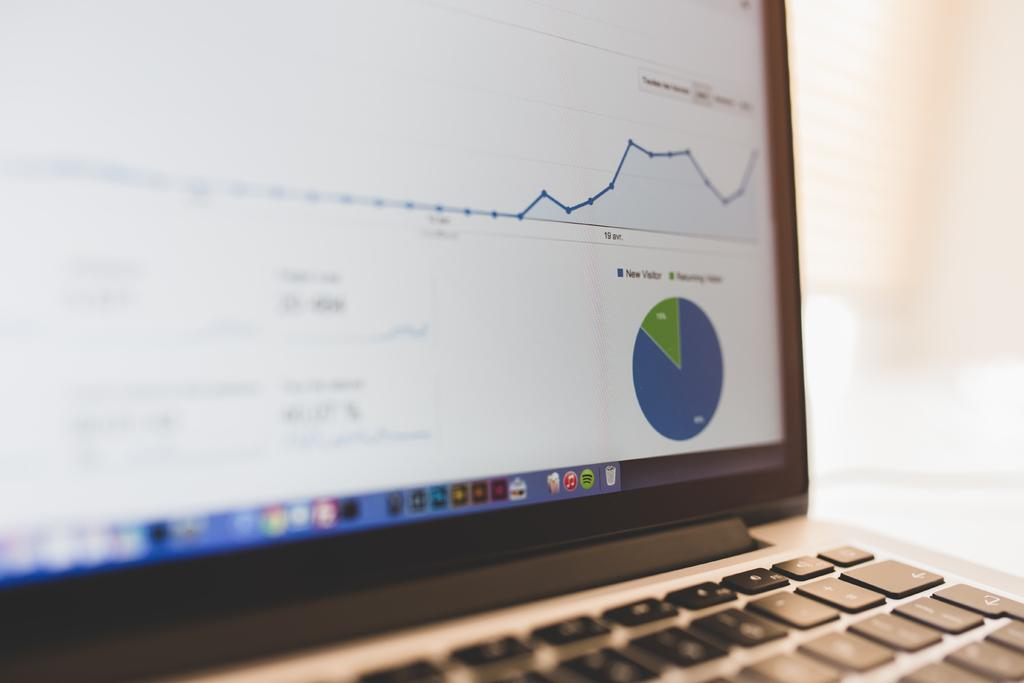<image>
Relay a brief, clear account of the picture shown. A pie chart shows category new visitor in blue and another category in green. 